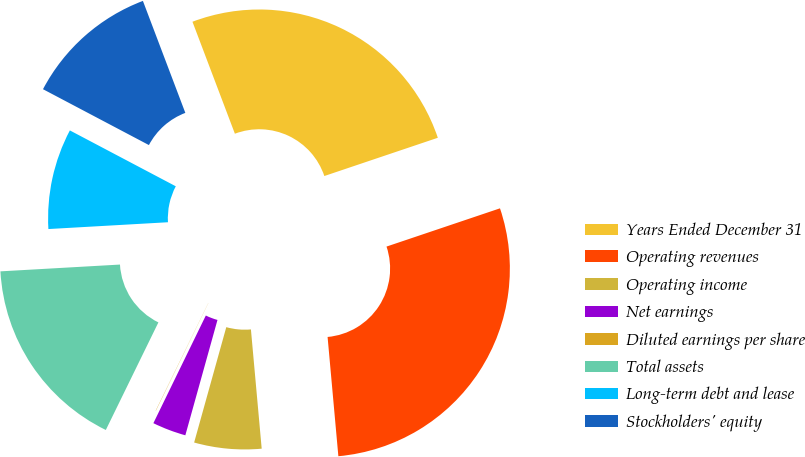Convert chart. <chart><loc_0><loc_0><loc_500><loc_500><pie_chart><fcel>Years Ended December 31<fcel>Operating revenues<fcel>Operating income<fcel>Net earnings<fcel>Diluted earnings per share<fcel>Total assets<fcel>Long-term debt and lease<fcel>Stockholders' equity<nl><fcel>25.59%<fcel>28.74%<fcel>5.76%<fcel>2.89%<fcel>0.02%<fcel>16.86%<fcel>8.63%<fcel>11.51%<nl></chart> 